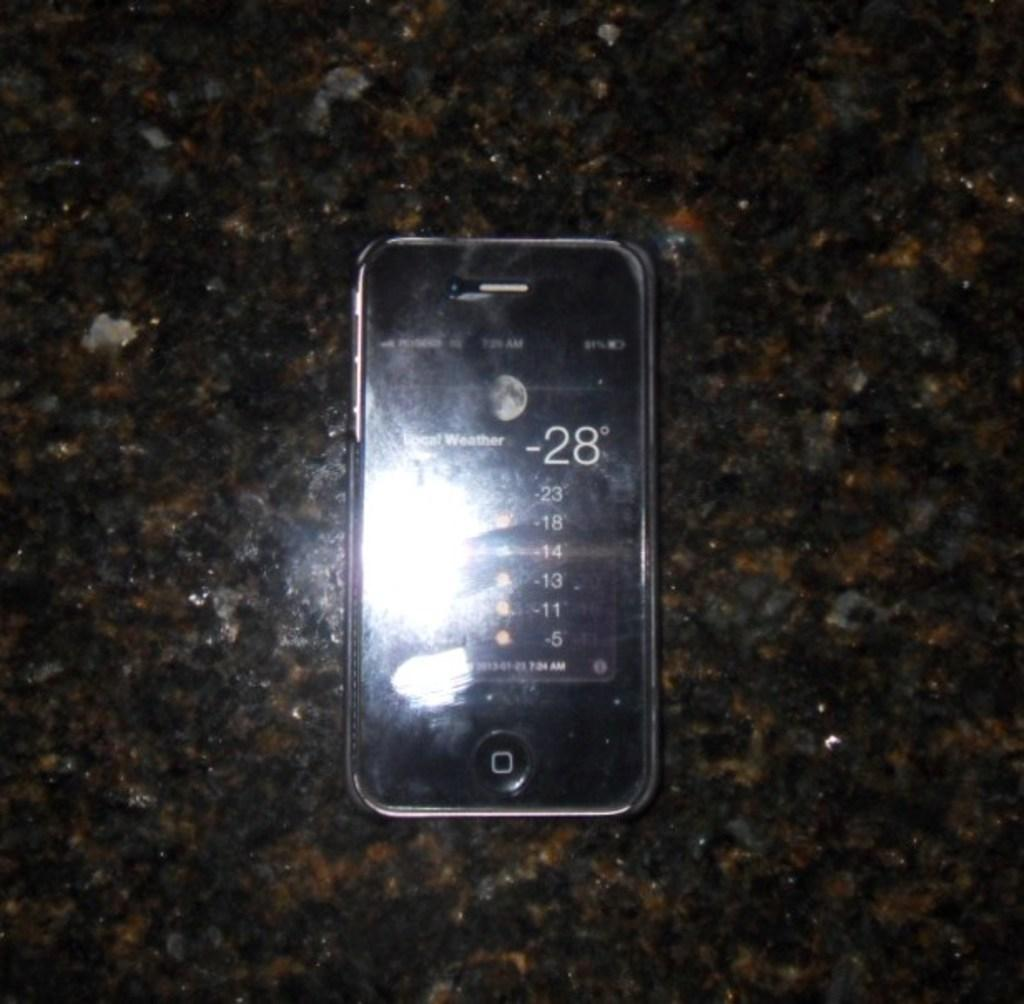<image>
Offer a succinct explanation of the picture presented. A smart phone early in the morning on a very cold night. 